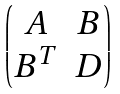Convert formula to latex. <formula><loc_0><loc_0><loc_500><loc_500>\begin{pmatrix} A & B \\ B ^ { T } & D \end{pmatrix}</formula> 